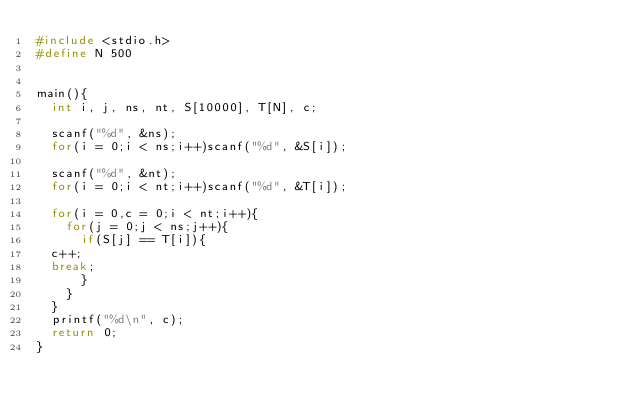<code> <loc_0><loc_0><loc_500><loc_500><_C_>#include <stdio.h>
#define N 500


main(){
  int i, j, ns, nt, S[10000], T[N], c;

  scanf("%d", &ns);
  for(i = 0;i < ns;i++)scanf("%d", &S[i]);

  scanf("%d", &nt);
  for(i = 0;i < nt;i++)scanf("%d", &T[i]);

  for(i = 0,c = 0;i < nt;i++){
    for(j = 0;j < ns;j++){
      if(S[j] == T[i]){
	c++;
	break;
      }
    }
  }
  printf("%d\n", c);
  return 0;
}</code> 